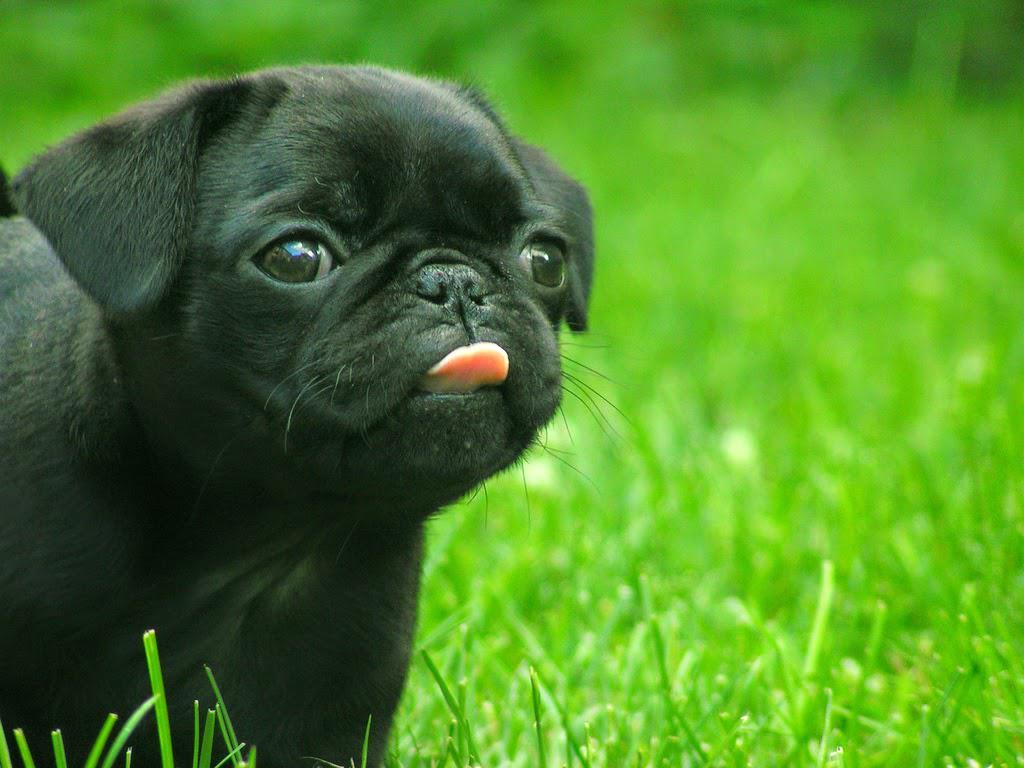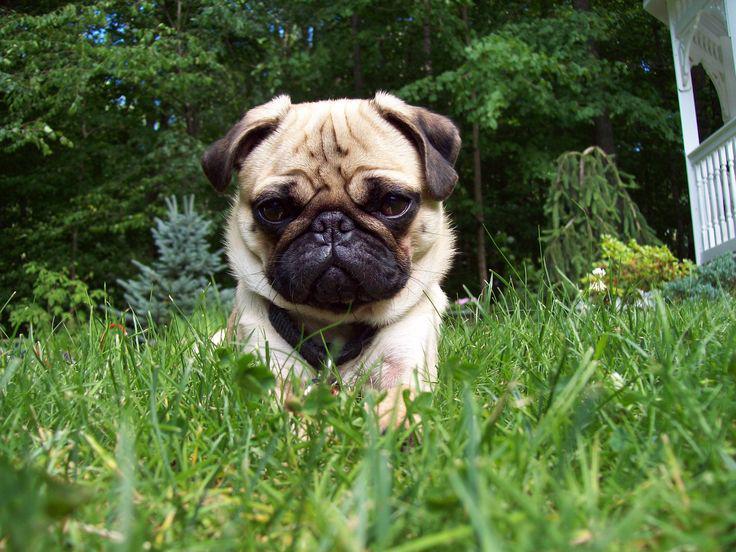The first image is the image on the left, the second image is the image on the right. Considering the images on both sides, is "I at least one image there is a pug looking straight forward wearing a costume that circles its head." valid? Answer yes or no. No. 